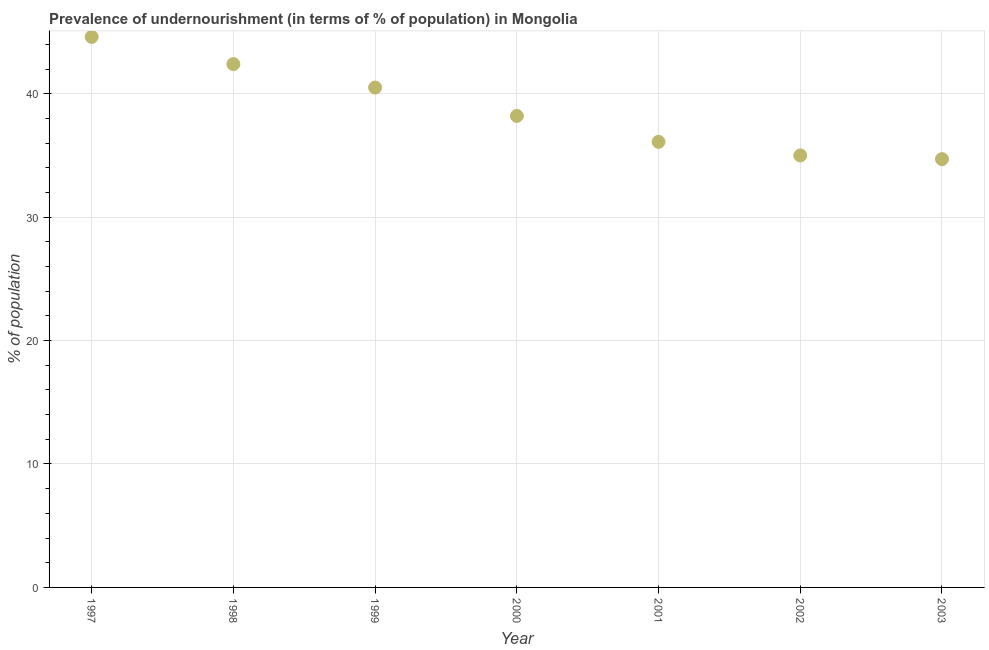What is the percentage of undernourished population in 1998?
Provide a succinct answer. 42.4. Across all years, what is the maximum percentage of undernourished population?
Your answer should be compact. 44.6. Across all years, what is the minimum percentage of undernourished population?
Offer a terse response. 34.7. In which year was the percentage of undernourished population maximum?
Provide a short and direct response. 1997. In which year was the percentage of undernourished population minimum?
Provide a short and direct response. 2003. What is the sum of the percentage of undernourished population?
Make the answer very short. 271.5. What is the difference between the percentage of undernourished population in 1998 and 1999?
Your answer should be very brief. 1.9. What is the average percentage of undernourished population per year?
Your response must be concise. 38.79. What is the median percentage of undernourished population?
Your answer should be compact. 38.2. What is the ratio of the percentage of undernourished population in 2000 to that in 2002?
Your answer should be compact. 1.09. What is the difference between the highest and the second highest percentage of undernourished population?
Provide a succinct answer. 2.2. What is the difference between the highest and the lowest percentage of undernourished population?
Ensure brevity in your answer.  9.9. How many dotlines are there?
Provide a short and direct response. 1. How many years are there in the graph?
Offer a very short reply. 7. What is the difference between two consecutive major ticks on the Y-axis?
Offer a very short reply. 10. Does the graph contain any zero values?
Ensure brevity in your answer.  No. What is the title of the graph?
Offer a terse response. Prevalence of undernourishment (in terms of % of population) in Mongolia. What is the label or title of the X-axis?
Your response must be concise. Year. What is the label or title of the Y-axis?
Your answer should be compact. % of population. What is the % of population in 1997?
Give a very brief answer. 44.6. What is the % of population in 1998?
Provide a short and direct response. 42.4. What is the % of population in 1999?
Give a very brief answer. 40.5. What is the % of population in 2000?
Provide a short and direct response. 38.2. What is the % of population in 2001?
Give a very brief answer. 36.1. What is the % of population in 2003?
Ensure brevity in your answer.  34.7. What is the difference between the % of population in 1997 and 1998?
Give a very brief answer. 2.2. What is the difference between the % of population in 1997 and 1999?
Offer a very short reply. 4.1. What is the difference between the % of population in 1997 and 2001?
Provide a short and direct response. 8.5. What is the difference between the % of population in 1997 and 2002?
Provide a succinct answer. 9.6. What is the difference between the % of population in 1997 and 2003?
Give a very brief answer. 9.9. What is the difference between the % of population in 1998 and 2002?
Provide a short and direct response. 7.4. What is the difference between the % of population in 1999 and 2000?
Keep it short and to the point. 2.3. What is the difference between the % of population in 2001 and 2003?
Keep it short and to the point. 1.4. What is the difference between the % of population in 2002 and 2003?
Offer a very short reply. 0.3. What is the ratio of the % of population in 1997 to that in 1998?
Offer a very short reply. 1.05. What is the ratio of the % of population in 1997 to that in 1999?
Your answer should be very brief. 1.1. What is the ratio of the % of population in 1997 to that in 2000?
Keep it short and to the point. 1.17. What is the ratio of the % of population in 1997 to that in 2001?
Offer a terse response. 1.24. What is the ratio of the % of population in 1997 to that in 2002?
Keep it short and to the point. 1.27. What is the ratio of the % of population in 1997 to that in 2003?
Give a very brief answer. 1.28. What is the ratio of the % of population in 1998 to that in 1999?
Provide a short and direct response. 1.05. What is the ratio of the % of population in 1998 to that in 2000?
Ensure brevity in your answer.  1.11. What is the ratio of the % of population in 1998 to that in 2001?
Keep it short and to the point. 1.18. What is the ratio of the % of population in 1998 to that in 2002?
Ensure brevity in your answer.  1.21. What is the ratio of the % of population in 1998 to that in 2003?
Your response must be concise. 1.22. What is the ratio of the % of population in 1999 to that in 2000?
Your response must be concise. 1.06. What is the ratio of the % of population in 1999 to that in 2001?
Offer a very short reply. 1.12. What is the ratio of the % of population in 1999 to that in 2002?
Offer a terse response. 1.16. What is the ratio of the % of population in 1999 to that in 2003?
Give a very brief answer. 1.17. What is the ratio of the % of population in 2000 to that in 2001?
Give a very brief answer. 1.06. What is the ratio of the % of population in 2000 to that in 2002?
Keep it short and to the point. 1.09. What is the ratio of the % of population in 2000 to that in 2003?
Your answer should be compact. 1.1. What is the ratio of the % of population in 2001 to that in 2002?
Make the answer very short. 1.03. What is the ratio of the % of population in 2001 to that in 2003?
Offer a very short reply. 1.04. What is the ratio of the % of population in 2002 to that in 2003?
Your response must be concise. 1.01. 